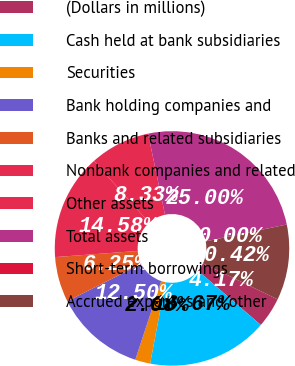Convert chart to OTSL. <chart><loc_0><loc_0><loc_500><loc_500><pie_chart><fcel>(Dollars in millions)<fcel>Cash held at bank subsidiaries<fcel>Securities<fcel>Bank holding companies and<fcel>Banks and related subsidiaries<fcel>Nonbank companies and related<fcel>Other assets<fcel>Total assets<fcel>Short-term borrowings<fcel>Accrued expenses and other<nl><fcel>4.17%<fcel>16.67%<fcel>2.08%<fcel>12.5%<fcel>6.25%<fcel>14.58%<fcel>8.33%<fcel>25.0%<fcel>0.0%<fcel>10.42%<nl></chart> 